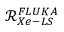Convert formula to latex. <formula><loc_0><loc_0><loc_500><loc_500>\mathcal { R } _ { X e - L S } ^ { F L U K A }</formula> 